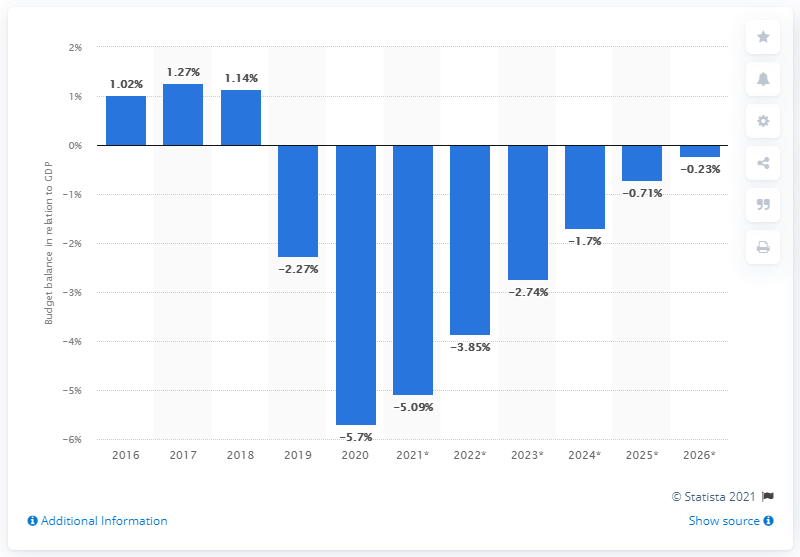Highlight a few significant elements in this photo. New Zealand's budget balance from 2016 to 2020 is shown in relation to the country's Gross Domestic Product. 